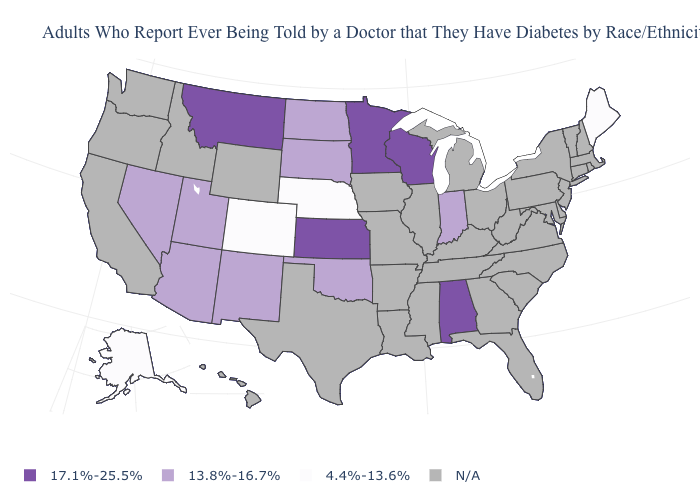Name the states that have a value in the range 4.4%-13.6%?
Keep it brief. Alaska, Colorado, Maine, Nebraska. Name the states that have a value in the range 13.8%-16.7%?
Keep it brief. Arizona, Indiana, Nevada, New Mexico, North Dakota, Oklahoma, South Dakota, Utah. Does Alabama have the highest value in the USA?
Answer briefly. Yes. What is the value of Ohio?
Quick response, please. N/A. Name the states that have a value in the range 17.1%-25.5%?
Short answer required. Alabama, Kansas, Minnesota, Montana, Wisconsin. What is the lowest value in the Northeast?
Answer briefly. 4.4%-13.6%. What is the value of Maryland?
Quick response, please. N/A. Which states have the lowest value in the USA?
Answer briefly. Alaska, Colorado, Maine, Nebraska. Does Wisconsin have the lowest value in the MidWest?
Short answer required. No. Which states have the lowest value in the USA?
Short answer required. Alaska, Colorado, Maine, Nebraska. Does Alabama have the lowest value in the USA?
Keep it brief. No. What is the value of Nebraska?
Short answer required. 4.4%-13.6%. What is the lowest value in the South?
Be succinct. 13.8%-16.7%. What is the value of Alaska?
Answer briefly. 4.4%-13.6%. 